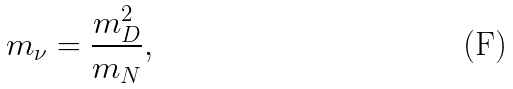Convert formula to latex. <formula><loc_0><loc_0><loc_500><loc_500>m _ { \nu } = \frac { m _ { D } ^ { 2 } } { m _ { N } } ,</formula> 